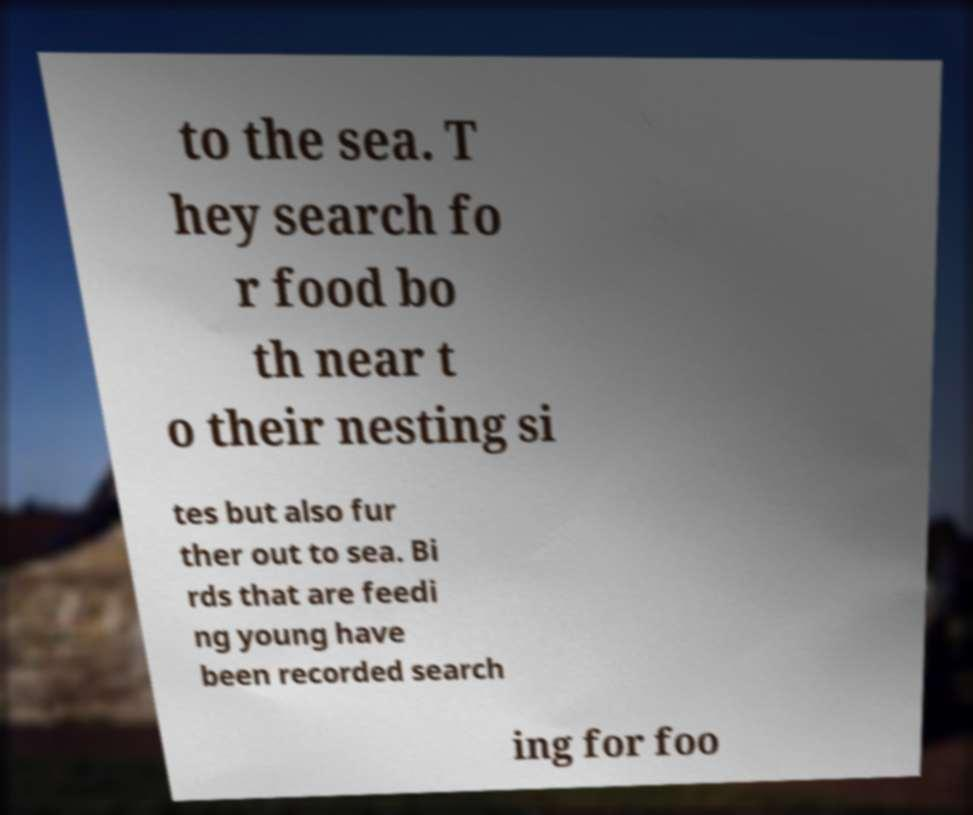Can you read and provide the text displayed in the image?This photo seems to have some interesting text. Can you extract and type it out for me? to the sea. T hey search fo r food bo th near t o their nesting si tes but also fur ther out to sea. Bi rds that are feedi ng young have been recorded search ing for foo 